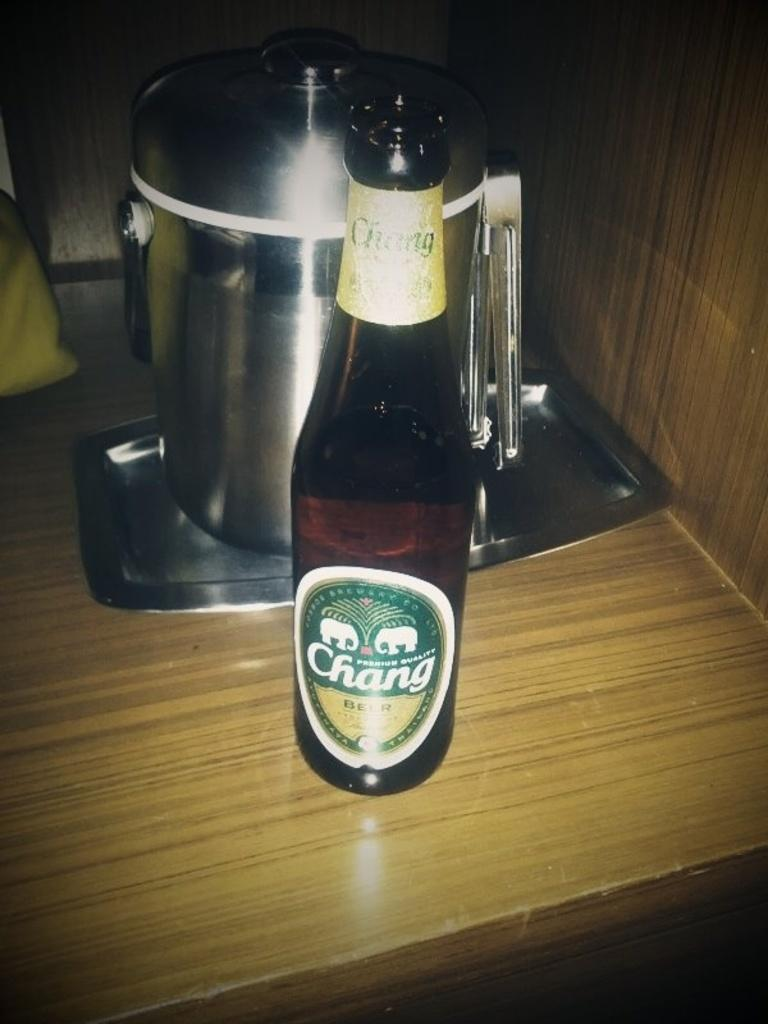Provide a one-sentence caption for the provided image. A bottle of Chang beer stands on a tan desk in front of a pot. 